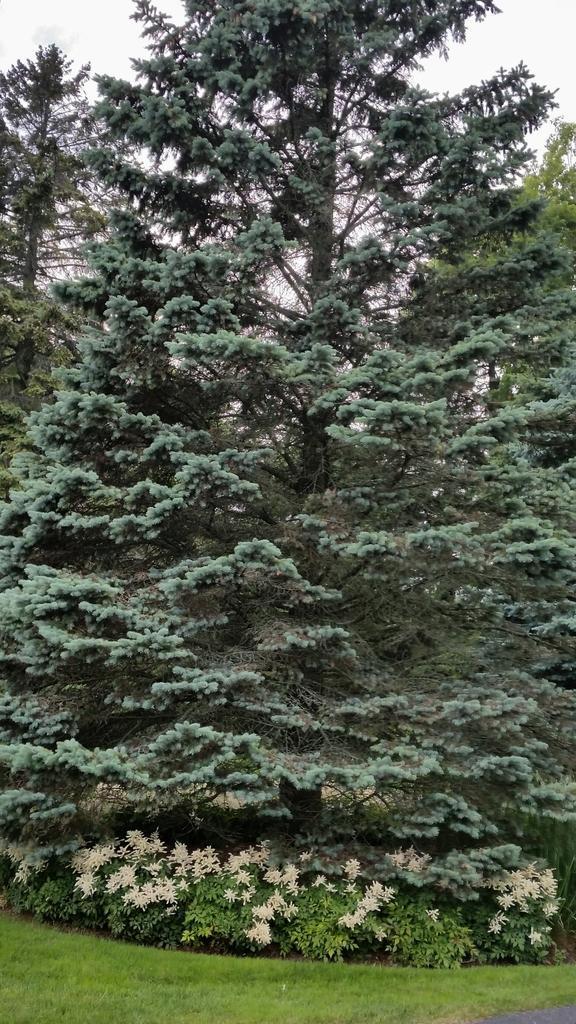Can you describe this image briefly? In the image we can see trees, plants, white flowers, grass and the sky. 